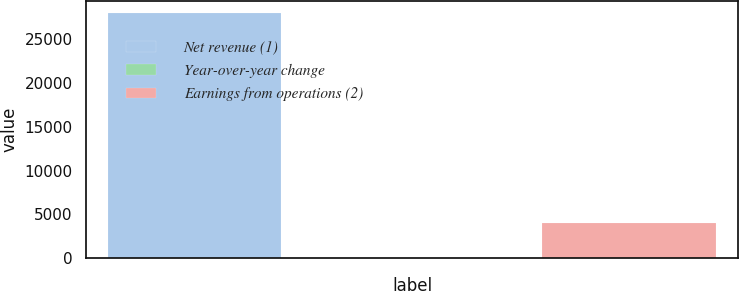<chart> <loc_0><loc_0><loc_500><loc_500><bar_chart><fcel>Net revenue (1)<fcel>Year-over-year change<fcel>Earnings from operations (2)<nl><fcel>27907<fcel>0.6<fcel>3981<nl></chart> 